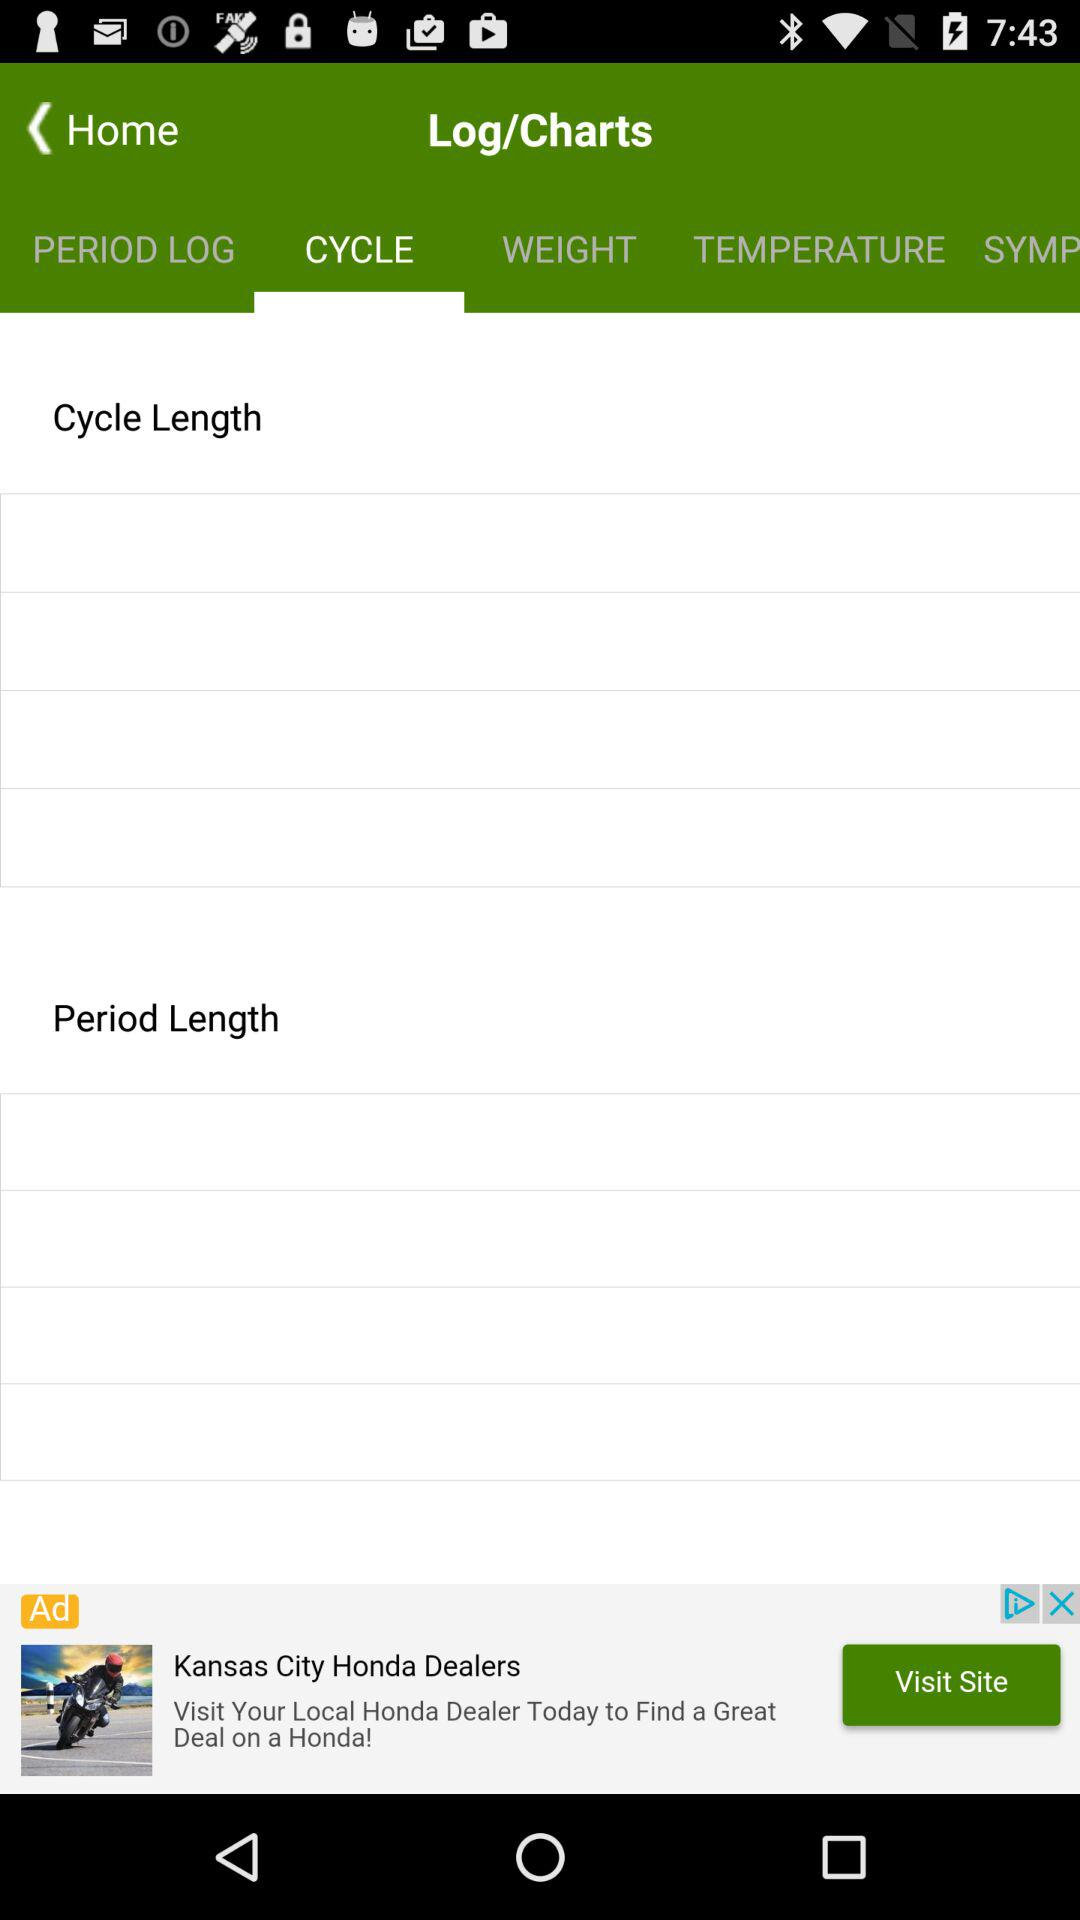What is the selected tab? The selected tab is "CYCLE". 